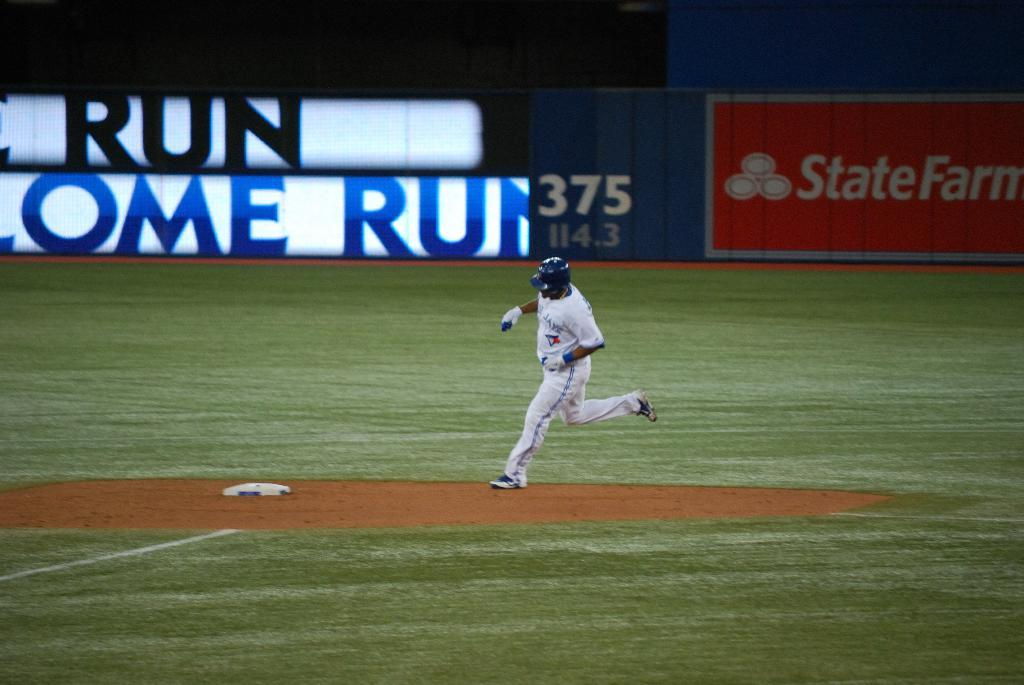Provide a one-sentence caption for the provided image. A base ball player runs to a plate with the words home run on a banner. 